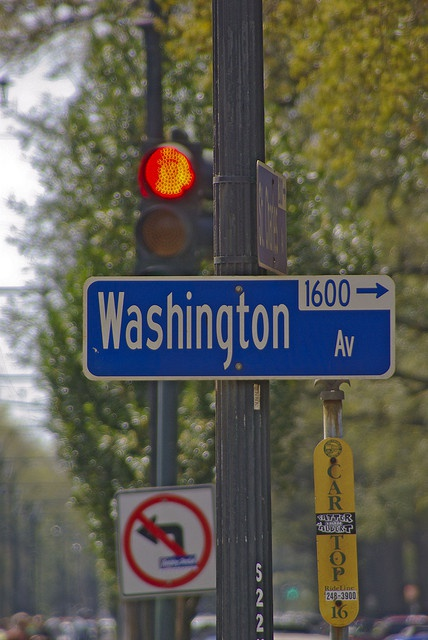Describe the objects in this image and their specific colors. I can see traffic light in gray, black, maroon, red, and orange tones and people in gray and maroon tones in this image. 